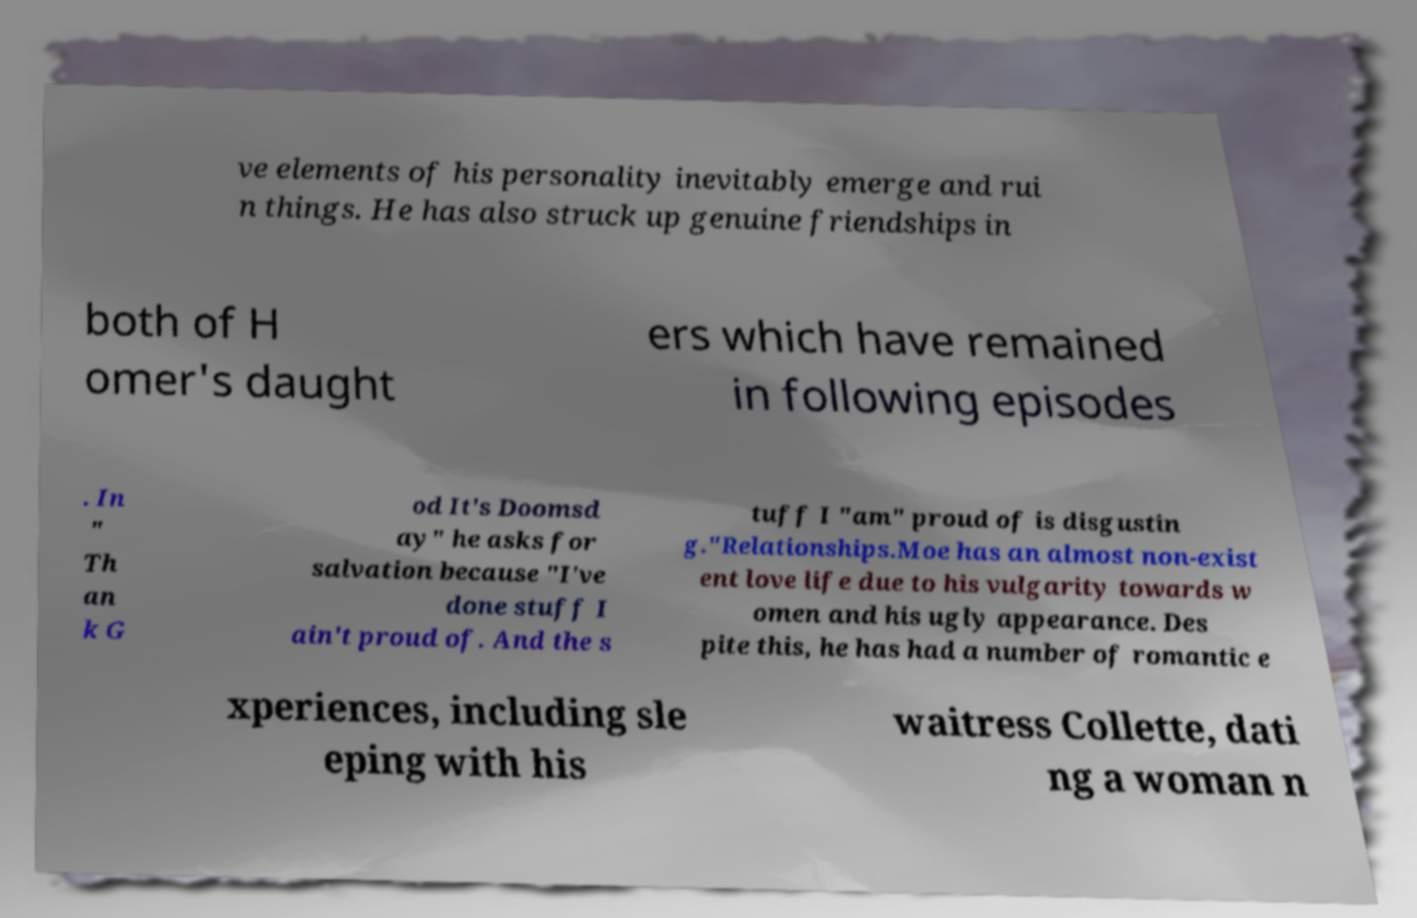Can you accurately transcribe the text from the provided image for me? ve elements of his personality inevitably emerge and rui n things. He has also struck up genuine friendships in both of H omer's daught ers which have remained in following episodes . In " Th an k G od It's Doomsd ay" he asks for salvation because "I've done stuff I ain't proud of. And the s tuff I "am" proud of is disgustin g."Relationships.Moe has an almost non-exist ent love life due to his vulgarity towards w omen and his ugly appearance. Des pite this, he has had a number of romantic e xperiences, including sle eping with his waitress Collette, dati ng a woman n 